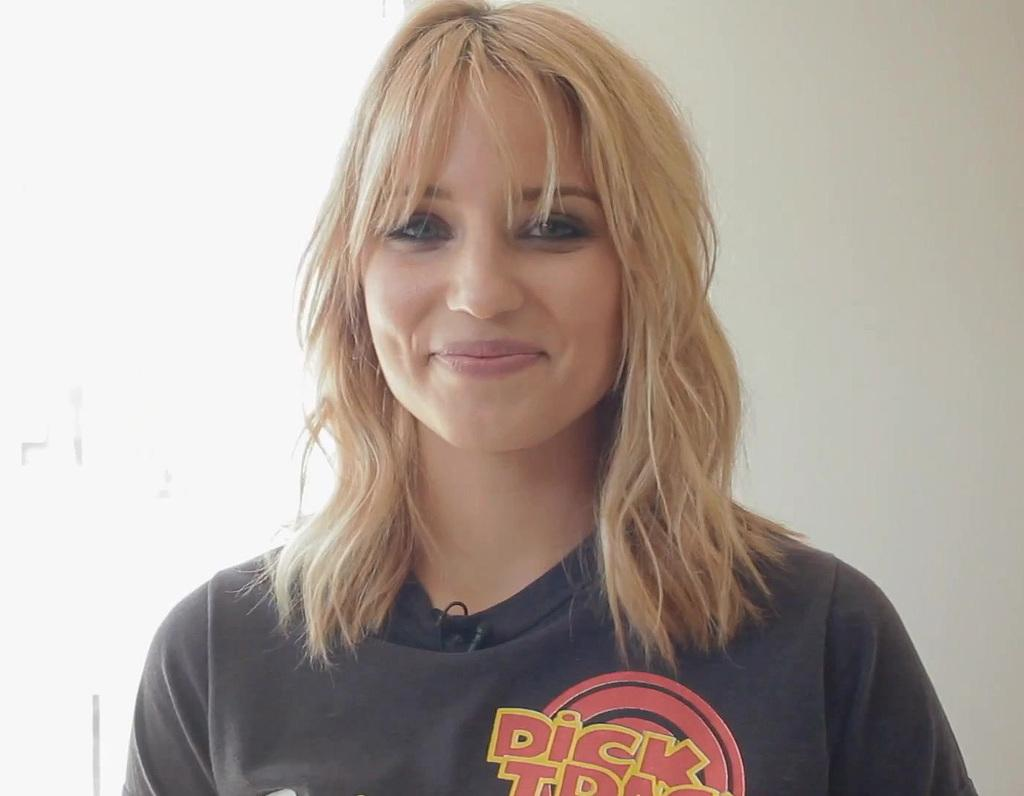<image>
Summarize the visual content of the image. A blonde woman in a black shirt has a logo with the word dick on it. 